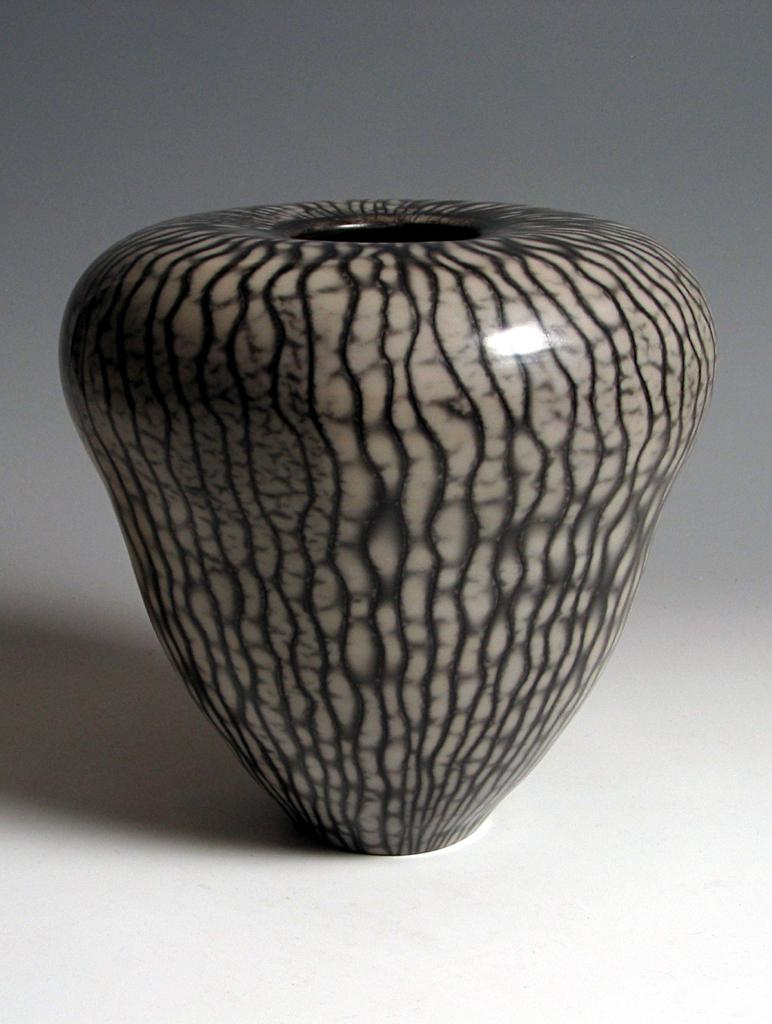What type of object is in the image? There is a ceramic jar in the image. What colors are used for the ceramic jar? The ceramic jar is cream and black in color. What is the jar placed on in the image? The ceramic jar is on a white colored surface. Can you see any silk material in the image? There is no silk material present in the image. How many times does the ceramic jar bite in the image? The ceramic jar does not bite in the image, as it is an inanimate object. 